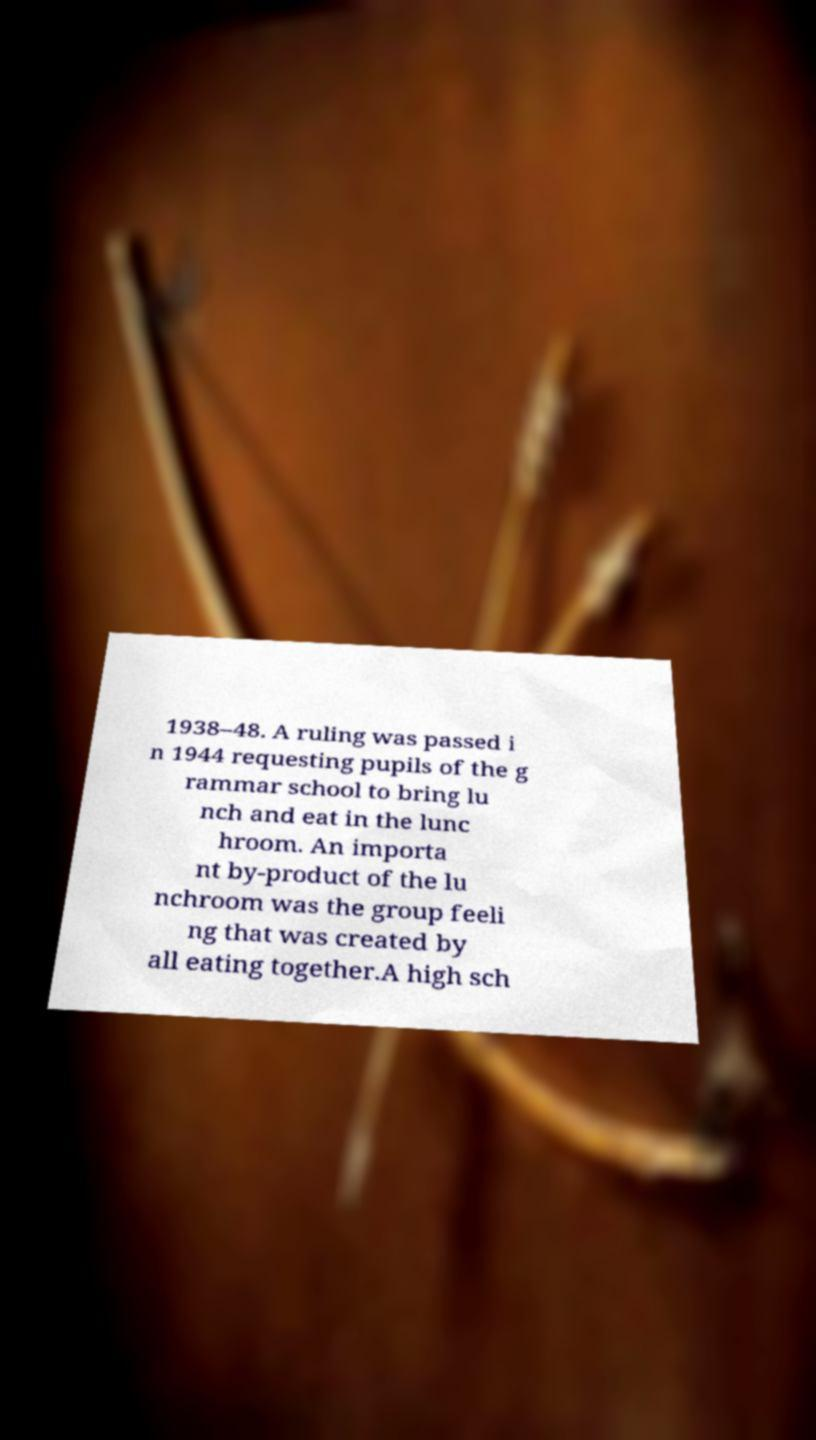Can you read and provide the text displayed in the image?This photo seems to have some interesting text. Can you extract and type it out for me? 1938–48. A ruling was passed i n 1944 requesting pupils of the g rammar school to bring lu nch and eat in the lunc hroom. An importa nt by-product of the lu nchroom was the group feeli ng that was created by all eating together.A high sch 